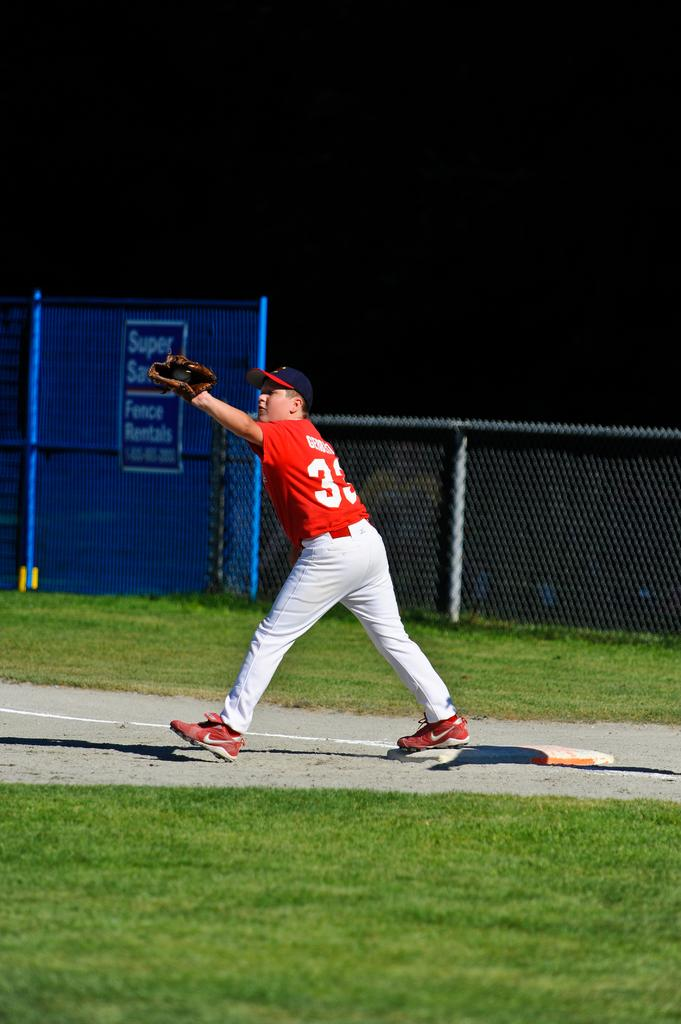<image>
Describe the image concisely. A baseball player has the number 33 on the back of his jersey. 